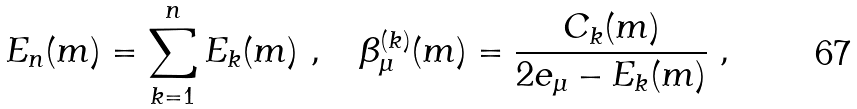Convert formula to latex. <formula><loc_0><loc_0><loc_500><loc_500>E _ { n } ( m ) = \sum _ { k = 1 } ^ { n } E _ { k } ( m ) \ , \quad \beta _ { \mu } ^ { ( k ) } ( m ) = \frac { C _ { k } ( m ) } { 2 e _ { \mu } - E _ { k } ( m ) } \ ,</formula> 